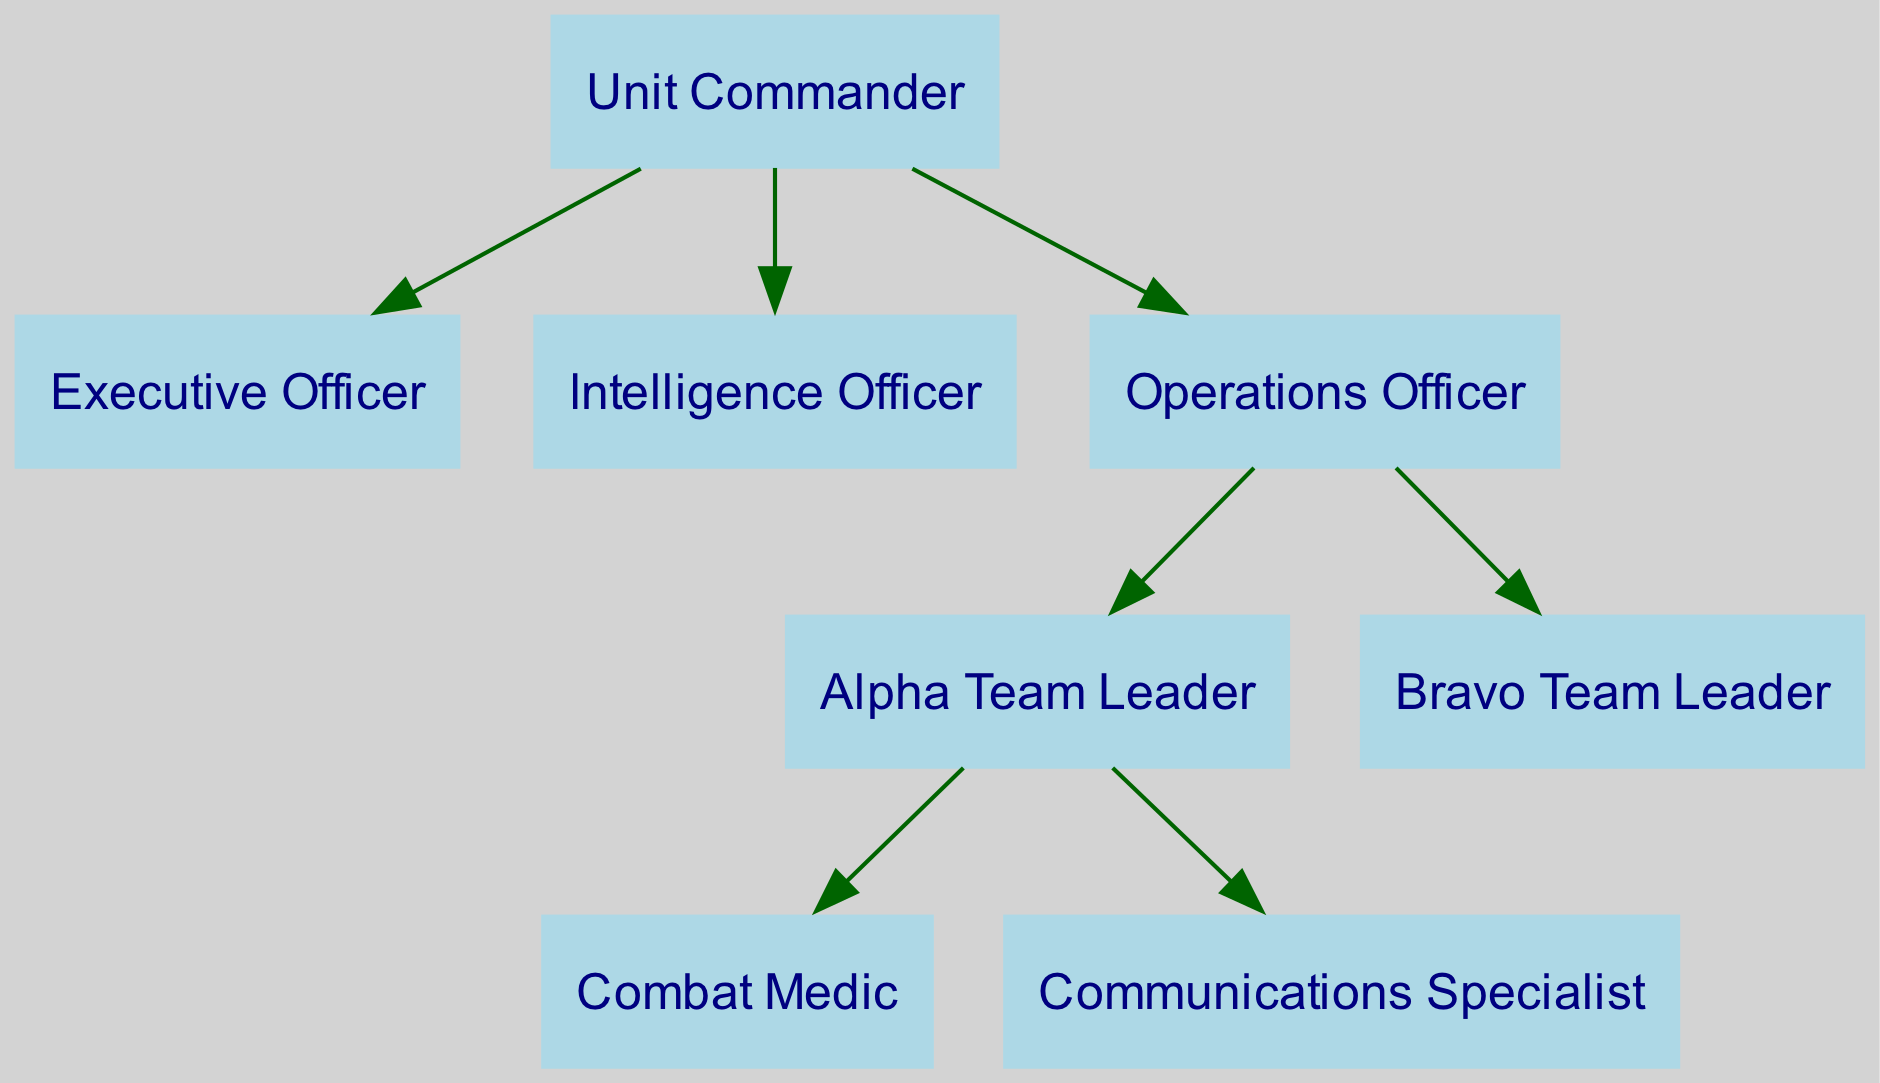What is the title of the diagram? The title is explicitly stated in the data provided as "U.S. Special Forces Unit Organizational Chart."
Answer: U.S. Special Forces Unit Organizational Chart Who reports directly to the Unit Commander? The edges in the diagram show that the Executive Officer, Intelligence Officer, and Operations Officer all have direct connections from the Unit Commander, indicating that they report to him.
Answer: Executive Officer, Intelligence Officer, Operations Officer How many teams are represented in the diagram? By examining the nodes, we see two team leaders: Alpha Team Leader and Bravo Team Leader. Each of these represents a distinct team.
Answer: 2 What is the role of the node that is directly below the Operations Officer? The edges show that both the Alpha Team Leader and Bravo Team Leader are directly connected to the Operations Officer, indicating their subordinate roles in operations.
Answer: Alpha Team Leader, Bravo Team Leader Which role is at the highest level in the hierarchy? Level 1 of the hierarchy contains only the Unit Commander, making him the highest-ranking official in this organizational structure.
Answer: Unit Commander How many total nodes are present in the diagram? Counting each of the roles listed in the nodes section, including the commander, officers, team leaders, and specialists, gives a total of eight distinct nodes.
Answer: 8 What is the relationship between the Alpha Team Leader and the Combat Medic? The edge indicates that the Combat Medic is connected to the Alpha Team Leader, which means the medic is a subordinate or member of the Alpha team.
Answer: Alpha Team Leader Which officer is primarily responsible for intelligence tasks? Looking at the labeled nodes, the Intelligence Officer is specifically designated for tasks related to intelligence, as per the label assigned.
Answer: Intelligence Officer How many edges are connected to the Unit Commander? The diagram specifies three edges connecting from the Unit Commander to the Executive Officer, Intelligence Officer, and Operations Officer, confirming the number of direct reports.
Answer: 3 